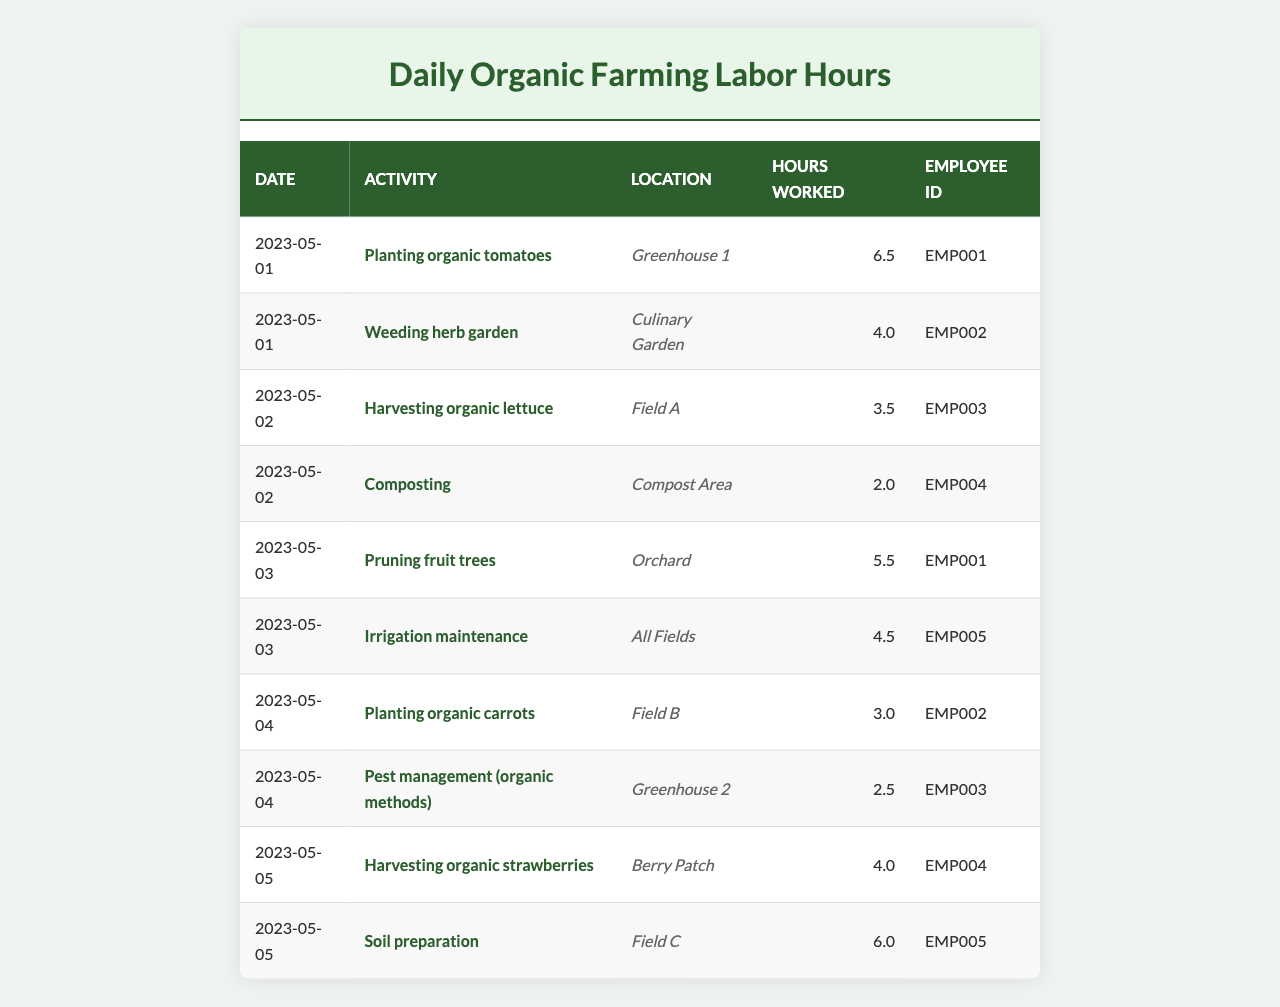What is the total number of hours worked on May 1? On May 1, the hours worked were 6.5 (Planting organic tomatoes) + 4.0 (Weeding herb garden) = 10.5 hours.
Answer: 10.5 Which activity took the most hours on May 3? On May 3, the activities were Pruning fruit trees (5.5 hours) and Irrigation maintenance (4.5 hours). The most hours worked is 5.5 for Pruning fruit trees.
Answer: Pruning fruit trees How many hours did employee EMP002 work in total? Employee EMP002 worked 4.0 hours on May 1 (Weeding herb garden) and 3.0 hours on May 4 (Planting organic carrots). The total is 4.0 + 3.0 = 7.0 hours.
Answer: 7.0 Was there any activity where less than 3 hours were recorded? The activity on May 2 (Composting) recorded 2.0 hours, which is less than 3 hours.
Answer: Yes What was the average number of hours worked per activity for the week? The total hours worked in the week is 6.5 + 4.0 + 3.5 + 2.0 + 5.5 + 4.5 + 3.0 + 2.5 + 4.0 + 6.0 = 42.5 hours. There are 10 activities, so the average is 42.5 / 10 = 4.25 hours per activity.
Answer: 4.25 How many activities were done in the Greenhouse? There were two activities done in the Greenhouse: Planting organic tomatoes on May 1 and Pest management (organic methods) on May 4.
Answer: 2 Which date had the least total hours worked? Examining the hours, May 2 has 3.5 hours (Harvesting organic lettuce) + 2.0 hours (Composting) = 5.5 hours, which is the lowest total for any date in this dataset.
Answer: May 2 What are the total hours worked by each employee? Employee EMP001 worked 6.5 (May 1) + 5.5 (May 3) = 12.0 hours; EMP002 worked 4.0 (May 1) + 3.0 (May 4) = 7.0 hours; EMP003 worked 3.5 (May 2) + 2.5 (May 4) = 6.0 hours; EMP004 worked 2.0 (May 2) + 4.0 (May 5) = 6.0 hours; EMP005 worked 4.5 (May 3) + 6.0 (May 5) = 10.5 hours.
Answer: EMP001: 12.0, EMP002: 7.0, EMP003: 6.0, EMP004: 6.0, EMP005: 10.5 Which location had the highest total hours recorded? To find the highest total, we sum the hours for each location: Greenhouse 1 (6.5), Culinary Garden (4.0), Field A (3.5), Compost Area (2.0), Orchard (5.5), All Fields (4.5), Field B (3.0), Greenhouse 2 (2.5), Berry Patch (4.0), Field C (6.0). The highest total is 10.5 from All Fields (4.5) and Field C (6.0).
Answer: All Fields Was there any activity that took more than 6 hours? There were no activities that recorded more than 6 hours; the maximum hours worked for any single activity was 6.5 hours (Planting organic tomatoes on May 1).
Answer: No 